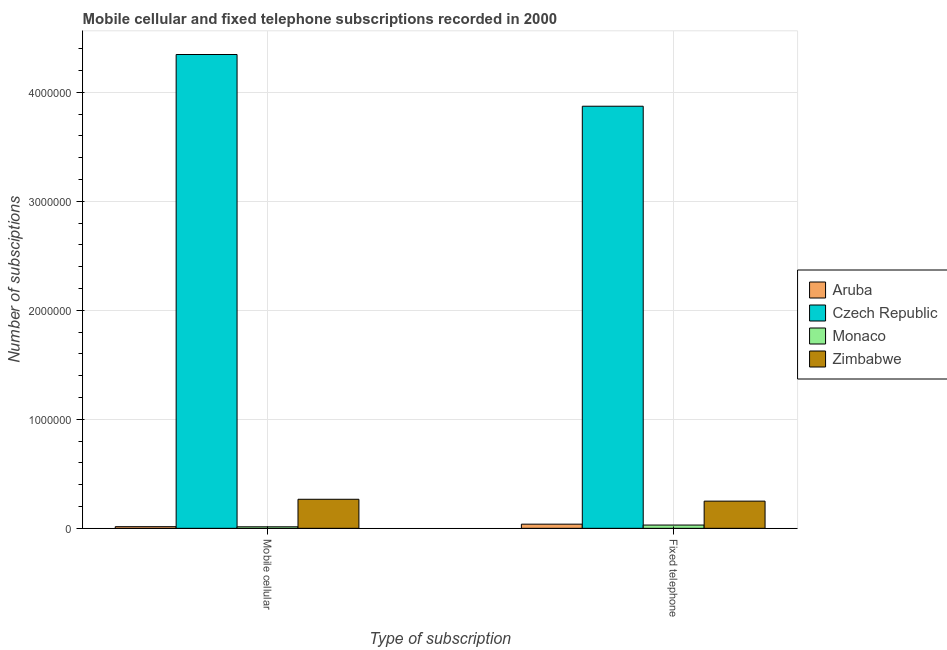How many different coloured bars are there?
Offer a very short reply. 4. How many bars are there on the 2nd tick from the right?
Keep it short and to the point. 4. What is the label of the 2nd group of bars from the left?
Ensure brevity in your answer.  Fixed telephone. What is the number of fixed telephone subscriptions in Zimbabwe?
Provide a short and direct response. 2.49e+05. Across all countries, what is the maximum number of fixed telephone subscriptions?
Provide a succinct answer. 3.87e+06. Across all countries, what is the minimum number of mobile cellular subscriptions?
Your response must be concise. 1.39e+04. In which country was the number of fixed telephone subscriptions maximum?
Keep it short and to the point. Czech Republic. In which country was the number of mobile cellular subscriptions minimum?
Your response must be concise. Monaco. What is the total number of fixed telephone subscriptions in the graph?
Offer a terse response. 4.19e+06. What is the difference between the number of mobile cellular subscriptions in Zimbabwe and that in Aruba?
Your answer should be very brief. 2.51e+05. What is the difference between the number of fixed telephone subscriptions in Aruba and the number of mobile cellular subscriptions in Czech Republic?
Provide a succinct answer. -4.31e+06. What is the average number of mobile cellular subscriptions per country?
Provide a short and direct response. 1.16e+06. What is the difference between the number of mobile cellular subscriptions and number of fixed telephone subscriptions in Czech Republic?
Your response must be concise. 4.74e+05. What is the ratio of the number of fixed telephone subscriptions in Zimbabwe to that in Czech Republic?
Offer a very short reply. 0.06. Is the number of fixed telephone subscriptions in Monaco less than that in Aruba?
Give a very brief answer. Yes. What does the 1st bar from the left in Mobile cellular represents?
Offer a terse response. Aruba. What does the 3rd bar from the right in Mobile cellular represents?
Your answer should be very brief. Czech Republic. Are all the bars in the graph horizontal?
Your response must be concise. No. How many countries are there in the graph?
Provide a short and direct response. 4. Are the values on the major ticks of Y-axis written in scientific E-notation?
Your answer should be compact. No. Does the graph contain grids?
Ensure brevity in your answer.  Yes. How are the legend labels stacked?
Your answer should be very brief. Vertical. What is the title of the graph?
Ensure brevity in your answer.  Mobile cellular and fixed telephone subscriptions recorded in 2000. What is the label or title of the X-axis?
Keep it short and to the point. Type of subscription. What is the label or title of the Y-axis?
Offer a terse response. Number of subsciptions. What is the Number of subsciptions in Aruba in Mobile cellular?
Keep it short and to the point. 1.50e+04. What is the Number of subsciptions in Czech Republic in Mobile cellular?
Give a very brief answer. 4.35e+06. What is the Number of subsciptions in Monaco in Mobile cellular?
Your response must be concise. 1.39e+04. What is the Number of subsciptions of Zimbabwe in Mobile cellular?
Your answer should be very brief. 2.66e+05. What is the Number of subsciptions in Aruba in Fixed telephone?
Provide a succinct answer. 3.81e+04. What is the Number of subsciptions in Czech Republic in Fixed telephone?
Your response must be concise. 3.87e+06. What is the Number of subsciptions of Monaco in Fixed telephone?
Offer a very short reply. 3.00e+04. What is the Number of subsciptions in Zimbabwe in Fixed telephone?
Provide a succinct answer. 2.49e+05. Across all Type of subscription, what is the maximum Number of subsciptions of Aruba?
Your answer should be compact. 3.81e+04. Across all Type of subscription, what is the maximum Number of subsciptions of Czech Republic?
Make the answer very short. 4.35e+06. Across all Type of subscription, what is the maximum Number of subsciptions of Monaco?
Offer a terse response. 3.00e+04. Across all Type of subscription, what is the maximum Number of subsciptions of Zimbabwe?
Your answer should be very brief. 2.66e+05. Across all Type of subscription, what is the minimum Number of subsciptions of Aruba?
Make the answer very short. 1.50e+04. Across all Type of subscription, what is the minimum Number of subsciptions in Czech Republic?
Your response must be concise. 3.87e+06. Across all Type of subscription, what is the minimum Number of subsciptions in Monaco?
Offer a terse response. 1.39e+04. Across all Type of subscription, what is the minimum Number of subsciptions in Zimbabwe?
Make the answer very short. 2.49e+05. What is the total Number of subsciptions in Aruba in the graph?
Provide a short and direct response. 5.31e+04. What is the total Number of subsciptions of Czech Republic in the graph?
Offer a terse response. 8.22e+06. What is the total Number of subsciptions of Monaco in the graph?
Provide a succinct answer. 4.39e+04. What is the total Number of subsciptions in Zimbabwe in the graph?
Offer a terse response. 5.16e+05. What is the difference between the Number of subsciptions of Aruba in Mobile cellular and that in Fixed telephone?
Provide a succinct answer. -2.31e+04. What is the difference between the Number of subsciptions in Czech Republic in Mobile cellular and that in Fixed telephone?
Your response must be concise. 4.74e+05. What is the difference between the Number of subsciptions of Monaco in Mobile cellular and that in Fixed telephone?
Provide a succinct answer. -1.60e+04. What is the difference between the Number of subsciptions of Zimbabwe in Mobile cellular and that in Fixed telephone?
Ensure brevity in your answer.  1.70e+04. What is the difference between the Number of subsciptions in Aruba in Mobile cellular and the Number of subsciptions in Czech Republic in Fixed telephone?
Provide a short and direct response. -3.86e+06. What is the difference between the Number of subsciptions of Aruba in Mobile cellular and the Number of subsciptions of Monaco in Fixed telephone?
Your response must be concise. -1.50e+04. What is the difference between the Number of subsciptions of Aruba in Mobile cellular and the Number of subsciptions of Zimbabwe in Fixed telephone?
Provide a short and direct response. -2.34e+05. What is the difference between the Number of subsciptions in Czech Republic in Mobile cellular and the Number of subsciptions in Monaco in Fixed telephone?
Offer a terse response. 4.32e+06. What is the difference between the Number of subsciptions of Czech Republic in Mobile cellular and the Number of subsciptions of Zimbabwe in Fixed telephone?
Your answer should be very brief. 4.10e+06. What is the difference between the Number of subsciptions in Monaco in Mobile cellular and the Number of subsciptions in Zimbabwe in Fixed telephone?
Offer a terse response. -2.35e+05. What is the average Number of subsciptions in Aruba per Type of subscription?
Your response must be concise. 2.66e+04. What is the average Number of subsciptions of Czech Republic per Type of subscription?
Give a very brief answer. 4.11e+06. What is the average Number of subsciptions in Monaco per Type of subscription?
Keep it short and to the point. 2.19e+04. What is the average Number of subsciptions of Zimbabwe per Type of subscription?
Your answer should be very brief. 2.58e+05. What is the difference between the Number of subsciptions in Aruba and Number of subsciptions in Czech Republic in Mobile cellular?
Give a very brief answer. -4.33e+06. What is the difference between the Number of subsciptions of Aruba and Number of subsciptions of Monaco in Mobile cellular?
Provide a short and direct response. 1073. What is the difference between the Number of subsciptions in Aruba and Number of subsciptions in Zimbabwe in Mobile cellular?
Your answer should be very brief. -2.51e+05. What is the difference between the Number of subsciptions of Czech Republic and Number of subsciptions of Monaco in Mobile cellular?
Provide a succinct answer. 4.33e+06. What is the difference between the Number of subsciptions in Czech Republic and Number of subsciptions in Zimbabwe in Mobile cellular?
Make the answer very short. 4.08e+06. What is the difference between the Number of subsciptions of Monaco and Number of subsciptions of Zimbabwe in Mobile cellular?
Keep it short and to the point. -2.53e+05. What is the difference between the Number of subsciptions of Aruba and Number of subsciptions of Czech Republic in Fixed telephone?
Make the answer very short. -3.83e+06. What is the difference between the Number of subsciptions of Aruba and Number of subsciptions of Monaco in Fixed telephone?
Your answer should be compact. 8131. What is the difference between the Number of subsciptions in Aruba and Number of subsciptions in Zimbabwe in Fixed telephone?
Your response must be concise. -2.11e+05. What is the difference between the Number of subsciptions in Czech Republic and Number of subsciptions in Monaco in Fixed telephone?
Offer a terse response. 3.84e+06. What is the difference between the Number of subsciptions in Czech Republic and Number of subsciptions in Zimbabwe in Fixed telephone?
Offer a very short reply. 3.62e+06. What is the difference between the Number of subsciptions of Monaco and Number of subsciptions of Zimbabwe in Fixed telephone?
Provide a succinct answer. -2.19e+05. What is the ratio of the Number of subsciptions in Aruba in Mobile cellular to that in Fixed telephone?
Your answer should be compact. 0.39. What is the ratio of the Number of subsciptions of Czech Republic in Mobile cellular to that in Fixed telephone?
Your response must be concise. 1.12. What is the ratio of the Number of subsciptions in Monaco in Mobile cellular to that in Fixed telephone?
Your answer should be compact. 0.46. What is the ratio of the Number of subsciptions in Zimbabwe in Mobile cellular to that in Fixed telephone?
Your answer should be very brief. 1.07. What is the difference between the highest and the second highest Number of subsciptions in Aruba?
Provide a short and direct response. 2.31e+04. What is the difference between the highest and the second highest Number of subsciptions in Czech Republic?
Give a very brief answer. 4.74e+05. What is the difference between the highest and the second highest Number of subsciptions in Monaco?
Offer a very short reply. 1.60e+04. What is the difference between the highest and the second highest Number of subsciptions in Zimbabwe?
Offer a very short reply. 1.70e+04. What is the difference between the highest and the lowest Number of subsciptions in Aruba?
Your answer should be very brief. 2.31e+04. What is the difference between the highest and the lowest Number of subsciptions in Czech Republic?
Your answer should be compact. 4.74e+05. What is the difference between the highest and the lowest Number of subsciptions of Monaco?
Your answer should be compact. 1.60e+04. What is the difference between the highest and the lowest Number of subsciptions of Zimbabwe?
Offer a very short reply. 1.70e+04. 